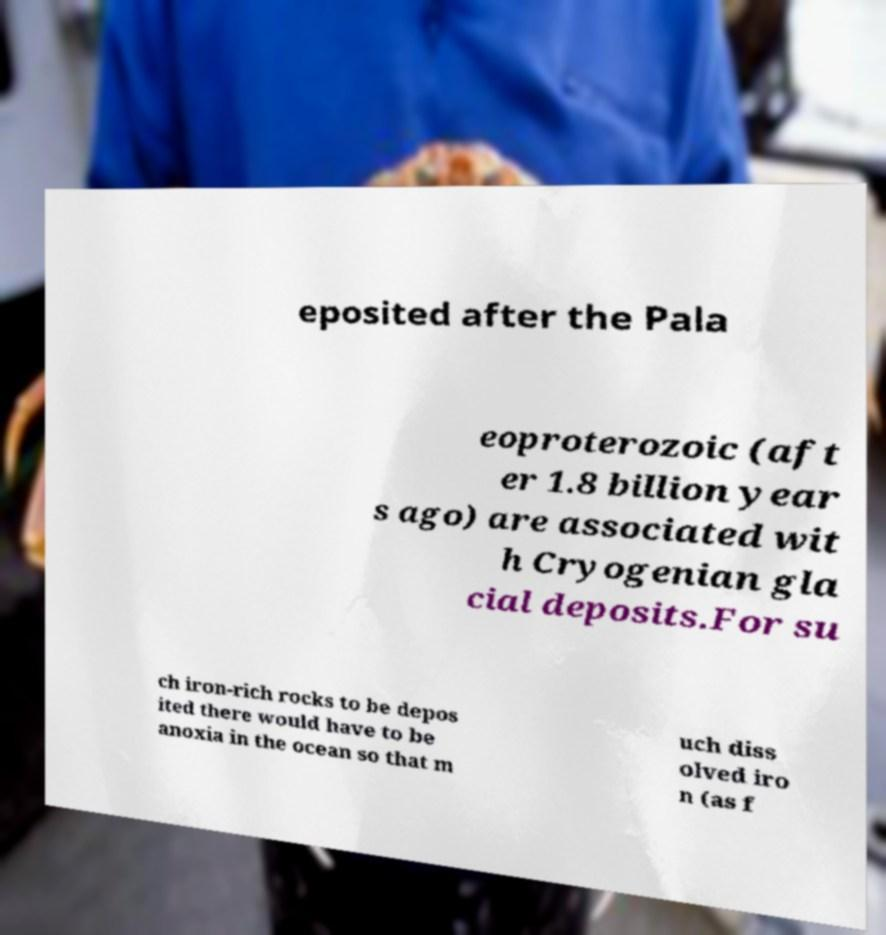Can you read and provide the text displayed in the image?This photo seems to have some interesting text. Can you extract and type it out for me? eposited after the Pala eoproterozoic (aft er 1.8 billion year s ago) are associated wit h Cryogenian gla cial deposits.For su ch iron-rich rocks to be depos ited there would have to be anoxia in the ocean so that m uch diss olved iro n (as f 